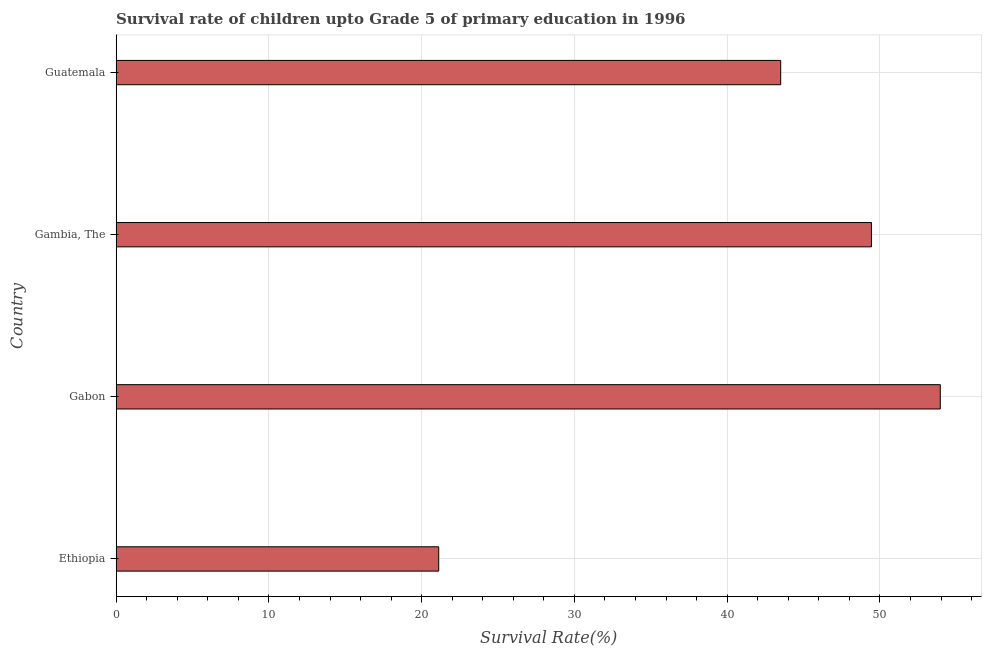Does the graph contain any zero values?
Make the answer very short. No. What is the title of the graph?
Keep it short and to the point. Survival rate of children upto Grade 5 of primary education in 1996 . What is the label or title of the X-axis?
Your answer should be compact. Survival Rate(%). What is the label or title of the Y-axis?
Provide a succinct answer. Country. What is the survival rate in Guatemala?
Offer a very short reply. 43.5. Across all countries, what is the maximum survival rate?
Ensure brevity in your answer.  53.95. Across all countries, what is the minimum survival rate?
Offer a terse response. 21.12. In which country was the survival rate maximum?
Keep it short and to the point. Gabon. In which country was the survival rate minimum?
Offer a very short reply. Ethiopia. What is the sum of the survival rate?
Make the answer very short. 168.01. What is the difference between the survival rate in Ethiopia and Gabon?
Your response must be concise. -32.83. What is the average survival rate per country?
Ensure brevity in your answer.  42. What is the median survival rate?
Offer a terse response. 46.47. In how many countries, is the survival rate greater than 46 %?
Make the answer very short. 2. What is the ratio of the survival rate in Gabon to that in Guatemala?
Provide a short and direct response. 1.24. Is the survival rate in Gabon less than that in Gambia, The?
Your answer should be compact. No. Is the difference between the survival rate in Gabon and Guatemala greater than the difference between any two countries?
Keep it short and to the point. No. What is the difference between the highest and the second highest survival rate?
Ensure brevity in your answer.  4.51. What is the difference between the highest and the lowest survival rate?
Give a very brief answer. 32.83. Are all the bars in the graph horizontal?
Give a very brief answer. Yes. How many countries are there in the graph?
Offer a very short reply. 4. What is the Survival Rate(%) of Ethiopia?
Provide a short and direct response. 21.12. What is the Survival Rate(%) of Gabon?
Make the answer very short. 53.95. What is the Survival Rate(%) of Gambia, The?
Provide a short and direct response. 49.44. What is the Survival Rate(%) of Guatemala?
Give a very brief answer. 43.5. What is the difference between the Survival Rate(%) in Ethiopia and Gabon?
Offer a very short reply. -32.83. What is the difference between the Survival Rate(%) in Ethiopia and Gambia, The?
Keep it short and to the point. -28.33. What is the difference between the Survival Rate(%) in Ethiopia and Guatemala?
Ensure brevity in your answer.  -22.39. What is the difference between the Survival Rate(%) in Gabon and Gambia, The?
Your answer should be very brief. 4.51. What is the difference between the Survival Rate(%) in Gabon and Guatemala?
Provide a succinct answer. 10.45. What is the difference between the Survival Rate(%) in Gambia, The and Guatemala?
Offer a terse response. 5.94. What is the ratio of the Survival Rate(%) in Ethiopia to that in Gabon?
Your response must be concise. 0.39. What is the ratio of the Survival Rate(%) in Ethiopia to that in Gambia, The?
Your answer should be compact. 0.43. What is the ratio of the Survival Rate(%) in Ethiopia to that in Guatemala?
Provide a succinct answer. 0.48. What is the ratio of the Survival Rate(%) in Gabon to that in Gambia, The?
Keep it short and to the point. 1.09. What is the ratio of the Survival Rate(%) in Gabon to that in Guatemala?
Your response must be concise. 1.24. What is the ratio of the Survival Rate(%) in Gambia, The to that in Guatemala?
Ensure brevity in your answer.  1.14. 